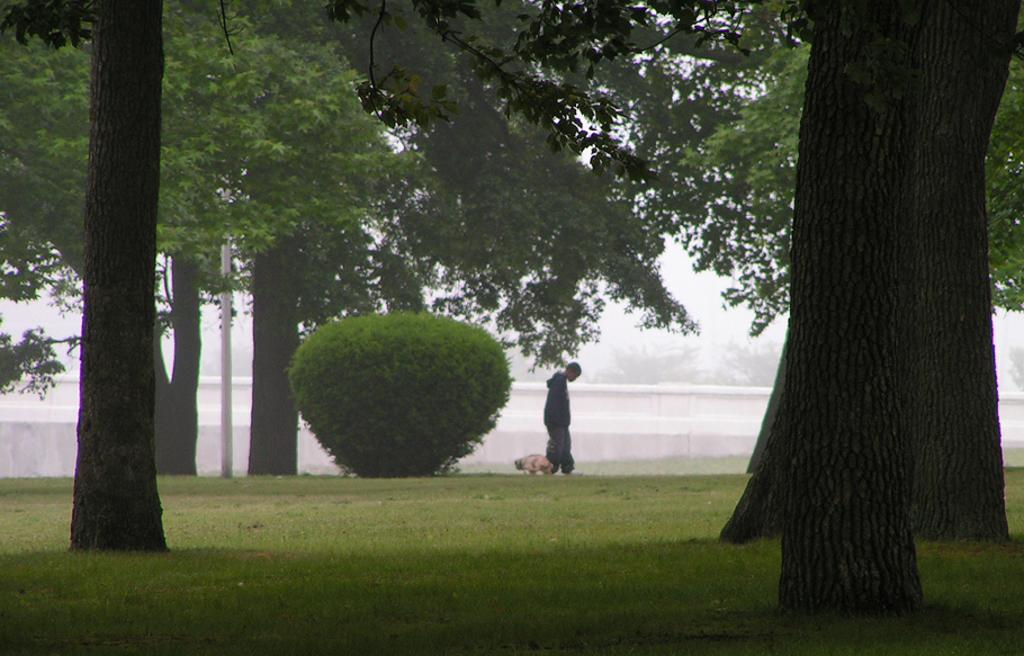What type of animal is in the image? There is an animal in the image, but its specific type cannot be determined from the provided facts. Who is present in the image besides the animal? There is a person in the image. Where is the person located in the image? The person is on the grass. What can be seen in the image besides the animal and person? There is a pole, trees, and a wall visible in the image. What type of pump is being used by the person in the image? There is no pump present in the image; it features an animal, a person, a pole, trees, and a wall. How does the person's mouth look like in the image? The provided facts do not mention the person's mouth, so it cannot be described. 